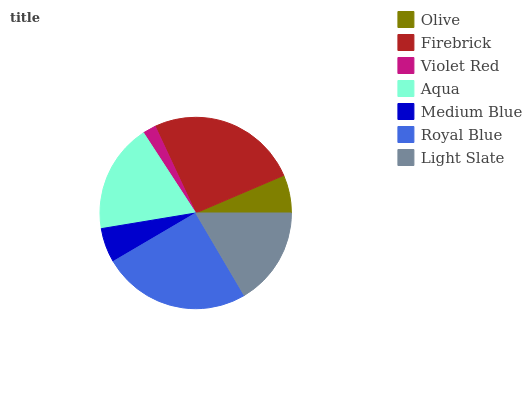Is Violet Red the minimum?
Answer yes or no. Yes. Is Firebrick the maximum?
Answer yes or no. Yes. Is Firebrick the minimum?
Answer yes or no. No. Is Violet Red the maximum?
Answer yes or no. No. Is Firebrick greater than Violet Red?
Answer yes or no. Yes. Is Violet Red less than Firebrick?
Answer yes or no. Yes. Is Violet Red greater than Firebrick?
Answer yes or no. No. Is Firebrick less than Violet Red?
Answer yes or no. No. Is Light Slate the high median?
Answer yes or no. Yes. Is Light Slate the low median?
Answer yes or no. Yes. Is Aqua the high median?
Answer yes or no. No. Is Violet Red the low median?
Answer yes or no. No. 